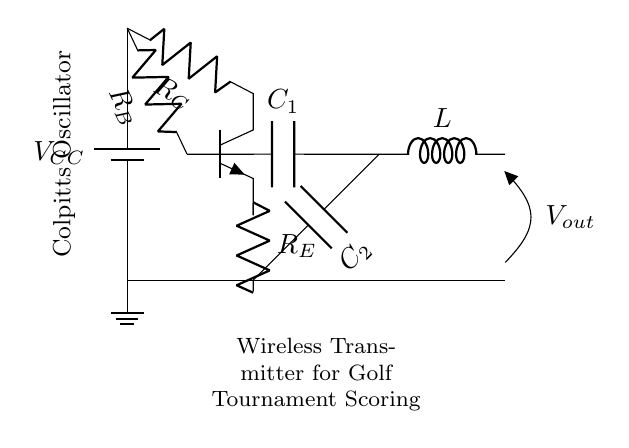What type of oscillator is shown in the circuit? The circuit diagram indicates that it is a Colpitts oscillator, which is typically identified by its specific arrangement of capacitors and inductors.
Answer: Colpitts What is the role of the transistor in the circuit? In this Colpitts oscillator circuit, the transistor acts as an amplifier, providing necessary gain for the oscillation to occur. The emitter and collector connections contribute to the feedback required for stable oscillations.
Answer: Amplifier How many capacitors are used in the circuit? The diagram shows two capacitors, labeled C1 and C2, which are essential for determining the oscillation frequency in the Colpitts configuration.
Answer: Two What is the output voltage associated with in the circuit? The output voltage, indicated as Vout, represents the electrical signal generated by the oscillation in the circuit; it shows where to measure the oscillating signal.
Answer: Vout What components make up the tank circuit in this oscillator? The tank circuit, crucial for sustaining oscillations, comprises the two capacitors (C1 and C2) and the inductor (L), which work together to establish the resonant frequency of the oscillator.
Answer: C1, C2, L Which component values primarily determine the oscillation frequency? The oscillation frequency is primarily determined by the values of the capacitors (C1, C2) and inductor (L) in the circuit, following the formula for a Colpitts oscillator.
Answer: C1, C2, L What type of signal is typically generated by this oscillator? The Colpitts oscillator generally produces a sine wave output, which is a common waveform used in wireless communication systems, such as those for scoring in golf tournaments.
Answer: Sine wave 